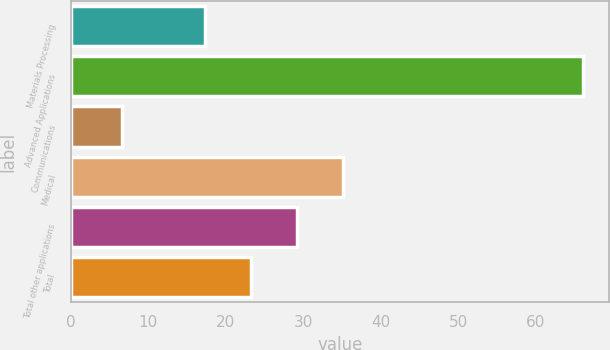Convert chart to OTSL. <chart><loc_0><loc_0><loc_500><loc_500><bar_chart><fcel>Materials Processing<fcel>Advanced Applications<fcel>Communications<fcel>Medical<fcel>Total other applications<fcel>Total<nl><fcel>17.3<fcel>66.1<fcel>6.6<fcel>35.15<fcel>29.2<fcel>23.25<nl></chart> 